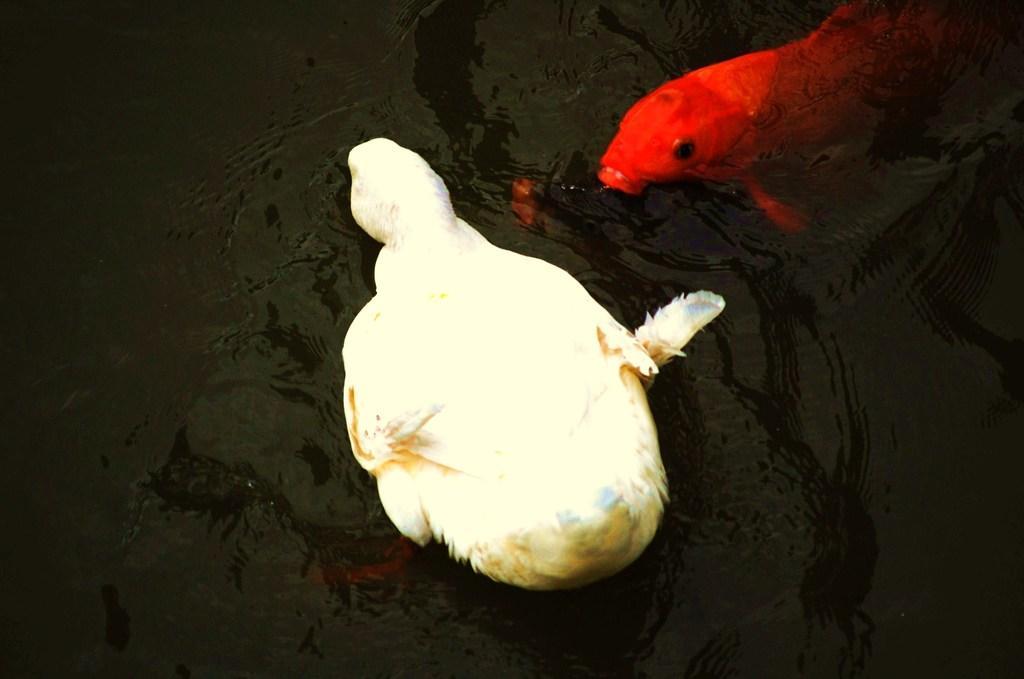Describe this image in one or two sentences. In this image I can see the bird and the fish in the water. The bird is in cream and brown color and the fish is in red color. 